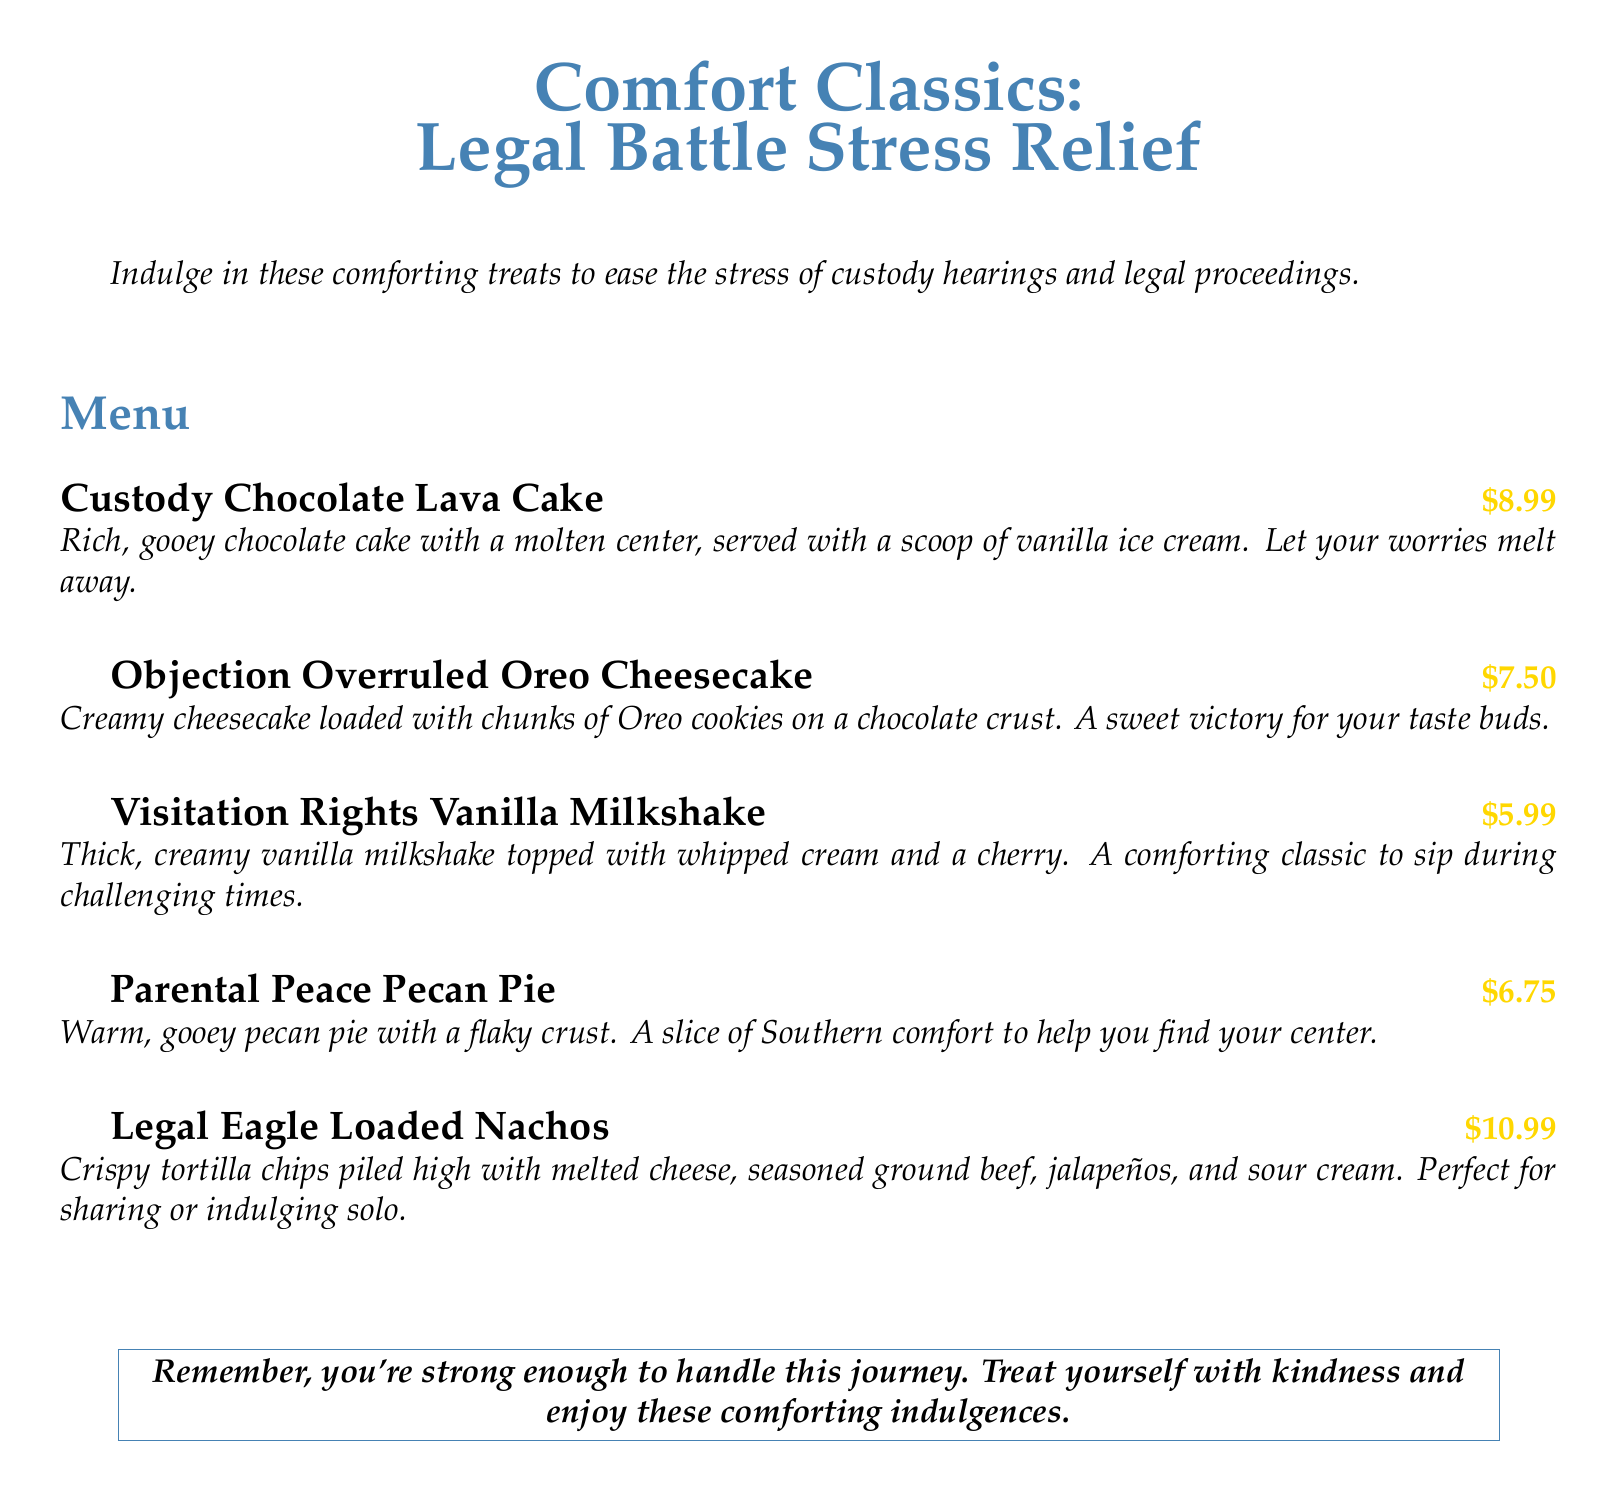What is the title of the menu section? The title of the menu section provides the theme of the items listed, which is "Legal Battle Stress Relief."
Answer: Legal Battle Stress Relief How much does the Custody Chocolate Lava Cake cost? The document lists the price of the Custody Chocolate Lava Cake, which is $8.99.
Answer: $8.99 What is the main ingredient in the Objection Overruled Oreo Cheesecake? The main ingredient highlighted in the Objection Overruled Oreo Cheesecake is Oreo cookies.
Answer: Oreo cookies What is included in the Visitation Rights Vanilla Milkshake? The Visitation Rights Vanilla Milkshake includes whipped cream and a cherry on top, as mentioned in the description.
Answer: Whipped cream and a cherry Which dessert is described as having a flaky crust? The dessert described with a flaky crust is the Parental Peace Pecan Pie.
Answer: Parental Peace Pecan Pie How many indulgent treats are listed in the menu? The menu lists a total of five indulgent treats.
Answer: Five What sentiment does the document convey at the end? The sentiment conveyed encourages treating oneself with kindness during a difficult period.
Answer: Kindness What type of food do the Legal Eagle Loaded Nachos represent? The Legal Eagle Loaded Nachos represent a shareable or indulgent food option as described in the menu.
Answer: Shareable or indulgent food option 